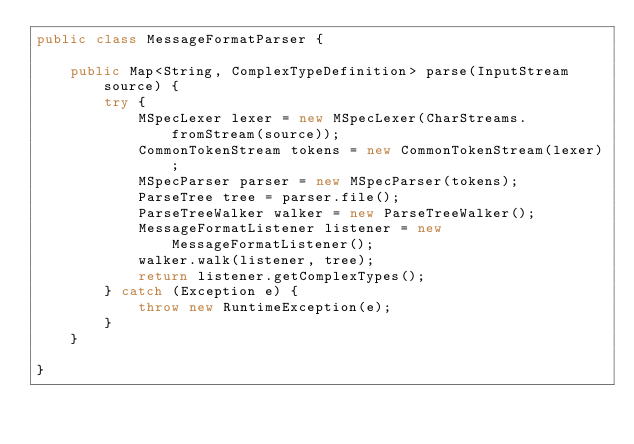<code> <loc_0><loc_0><loc_500><loc_500><_Java_>public class MessageFormatParser {

    public Map<String, ComplexTypeDefinition> parse(InputStream source) {
        try {
            MSpecLexer lexer = new MSpecLexer(CharStreams.fromStream(source));
            CommonTokenStream tokens = new CommonTokenStream(lexer);
            MSpecParser parser = new MSpecParser(tokens);
            ParseTree tree = parser.file();
            ParseTreeWalker walker = new ParseTreeWalker();
            MessageFormatListener listener = new MessageFormatListener();
            walker.walk(listener, tree);
            return listener.getComplexTypes();
        } catch (Exception e) {
            throw new RuntimeException(e);
        }
    }

}
</code> 